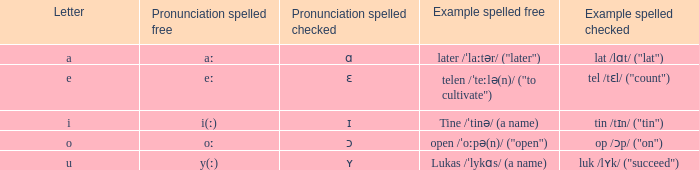What is Pronunciation Spelled Checked, when Example Spelled Checked is "tin /tɪn/ ("tin")" Ɪ. 